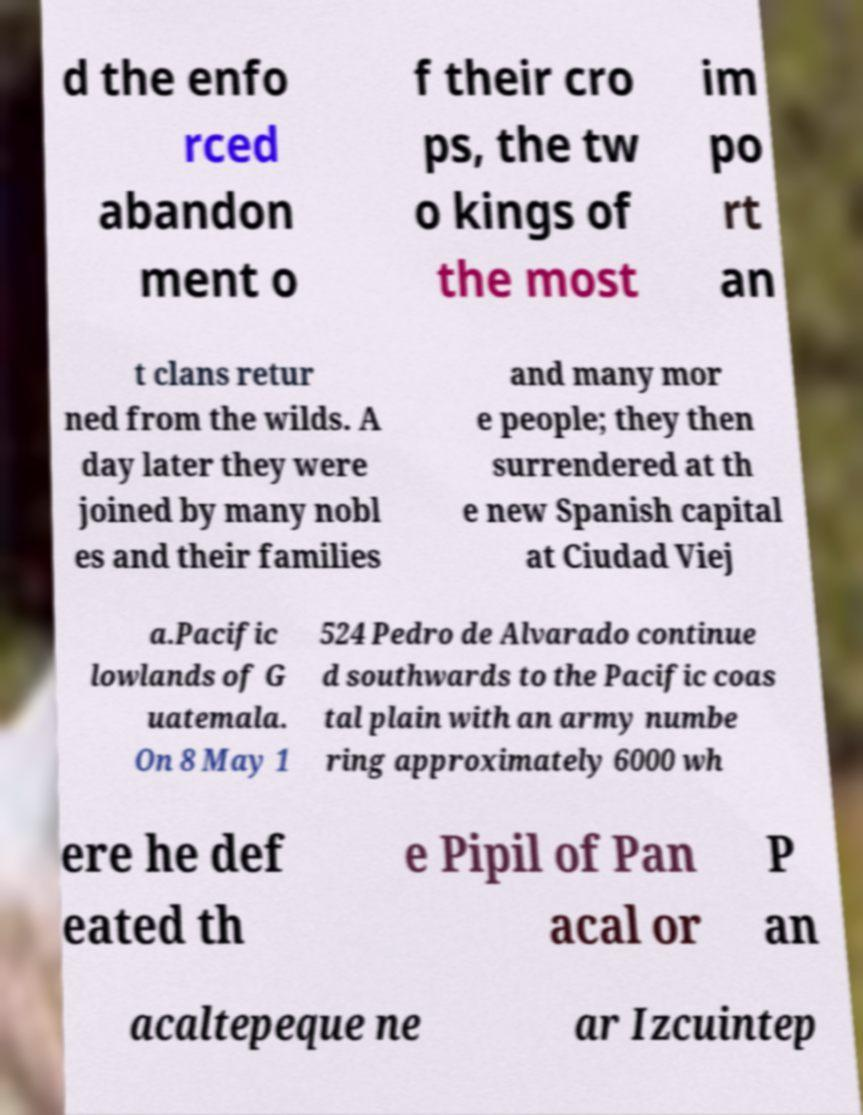There's text embedded in this image that I need extracted. Can you transcribe it verbatim? d the enfo rced abandon ment o f their cro ps, the tw o kings of the most im po rt an t clans retur ned from the wilds. A day later they were joined by many nobl es and their families and many mor e people; they then surrendered at th e new Spanish capital at Ciudad Viej a.Pacific lowlands of G uatemala. On 8 May 1 524 Pedro de Alvarado continue d southwards to the Pacific coas tal plain with an army numbe ring approximately 6000 wh ere he def eated th e Pipil of Pan acal or P an acaltepeque ne ar Izcuintep 